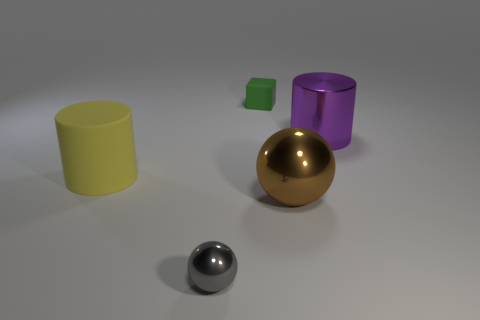Subtract 2 cylinders. How many cylinders are left? 0 Add 4 large brown things. How many objects exist? 9 Subtract all yellow spheres. Subtract all yellow blocks. How many spheres are left? 2 Subtract all large brown cylinders. Subtract all small green matte objects. How many objects are left? 4 Add 5 big purple metal cylinders. How many big purple metal cylinders are left? 6 Add 5 large objects. How many large objects exist? 8 Subtract 0 blue balls. How many objects are left? 5 Subtract all blocks. How many objects are left? 4 